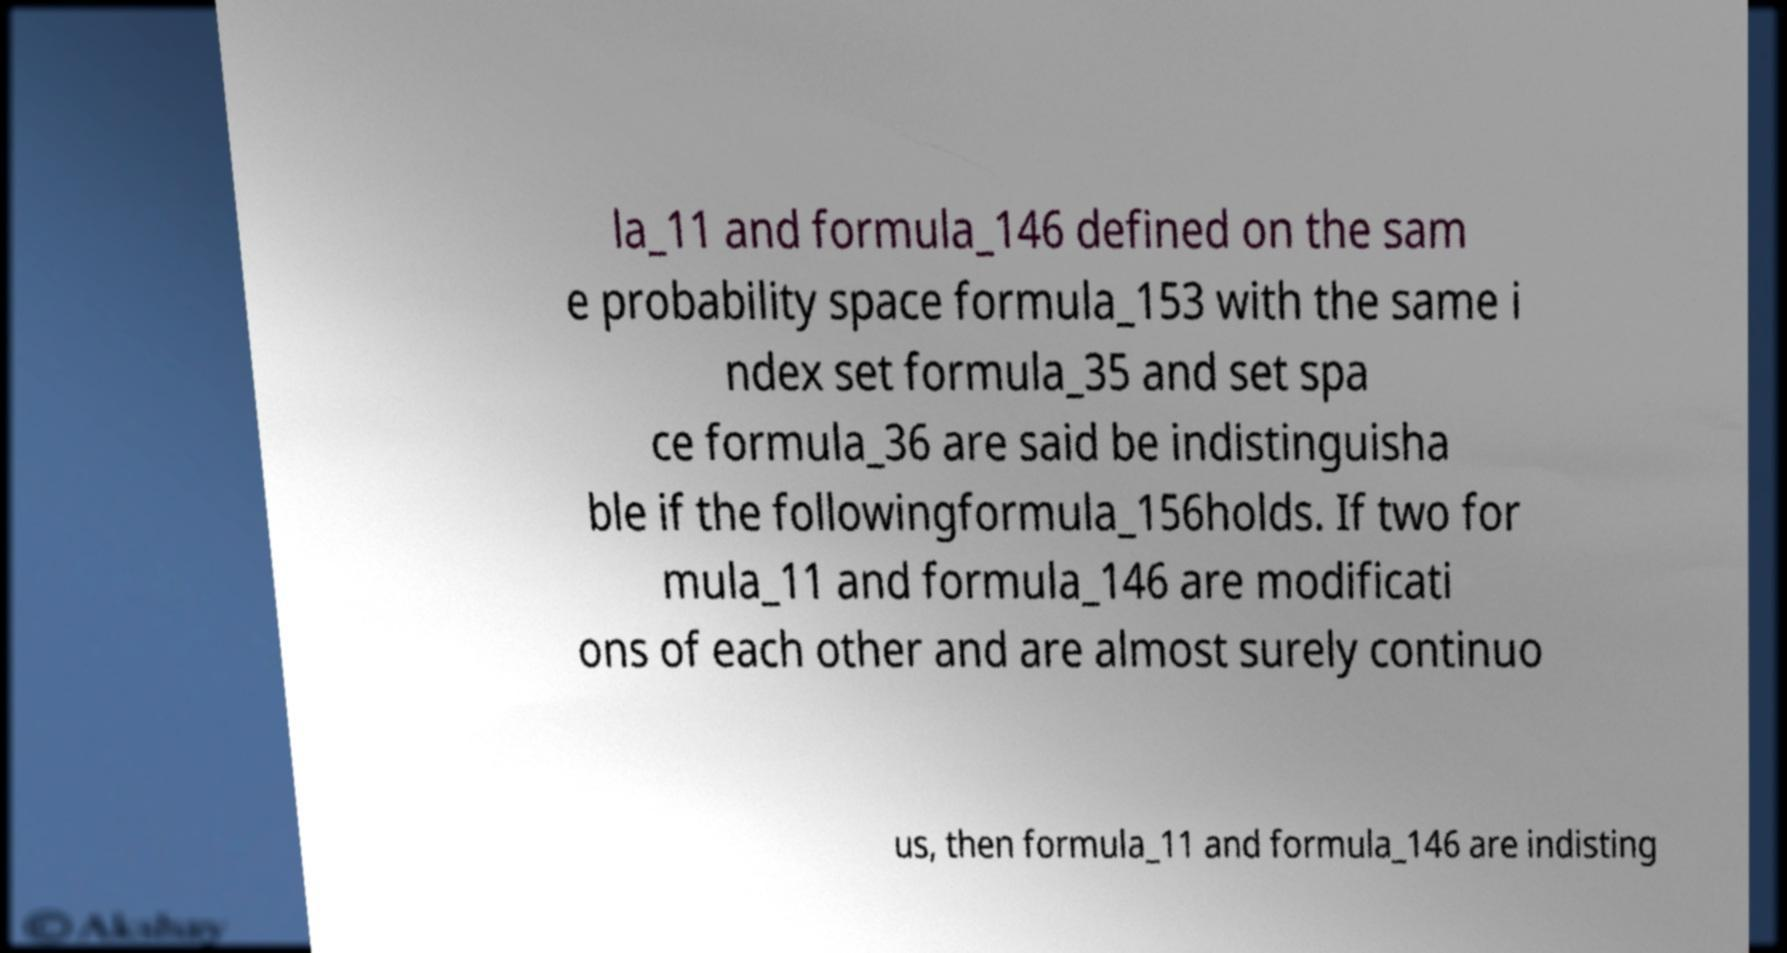Could you extract and type out the text from this image? la_11 and formula_146 defined on the sam e probability space formula_153 with the same i ndex set formula_35 and set spa ce formula_36 are said be indistinguisha ble if the followingformula_156holds. If two for mula_11 and formula_146 are modificati ons of each other and are almost surely continuo us, then formula_11 and formula_146 are indisting 